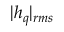<formula> <loc_0><loc_0><loc_500><loc_500>| h _ { q } | _ { r m s }</formula> 